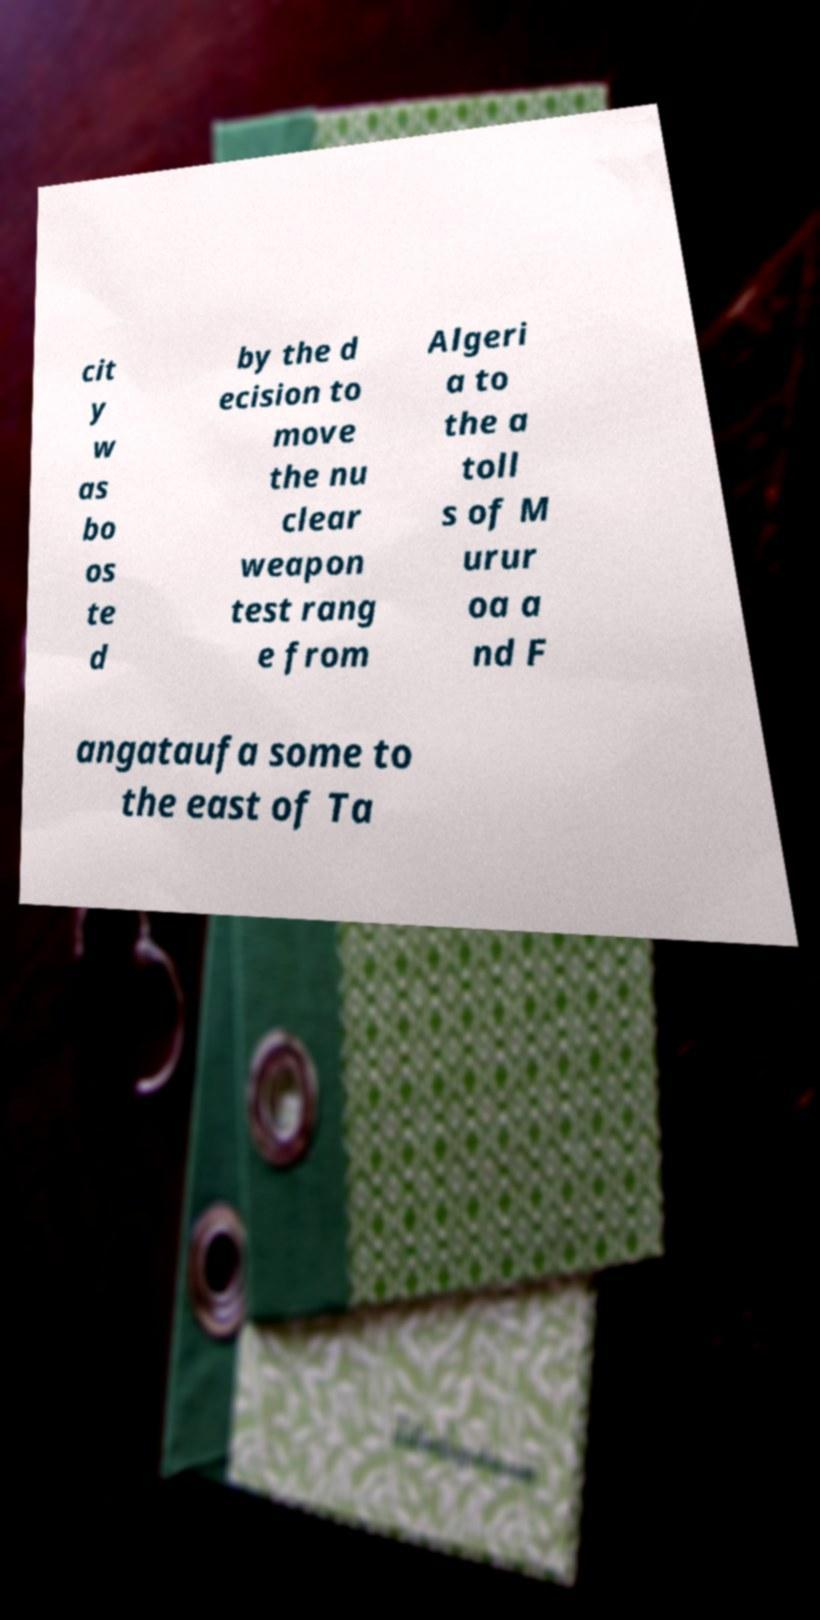For documentation purposes, I need the text within this image transcribed. Could you provide that? cit y w as bo os te d by the d ecision to move the nu clear weapon test rang e from Algeri a to the a toll s of M urur oa a nd F angataufa some to the east of Ta 